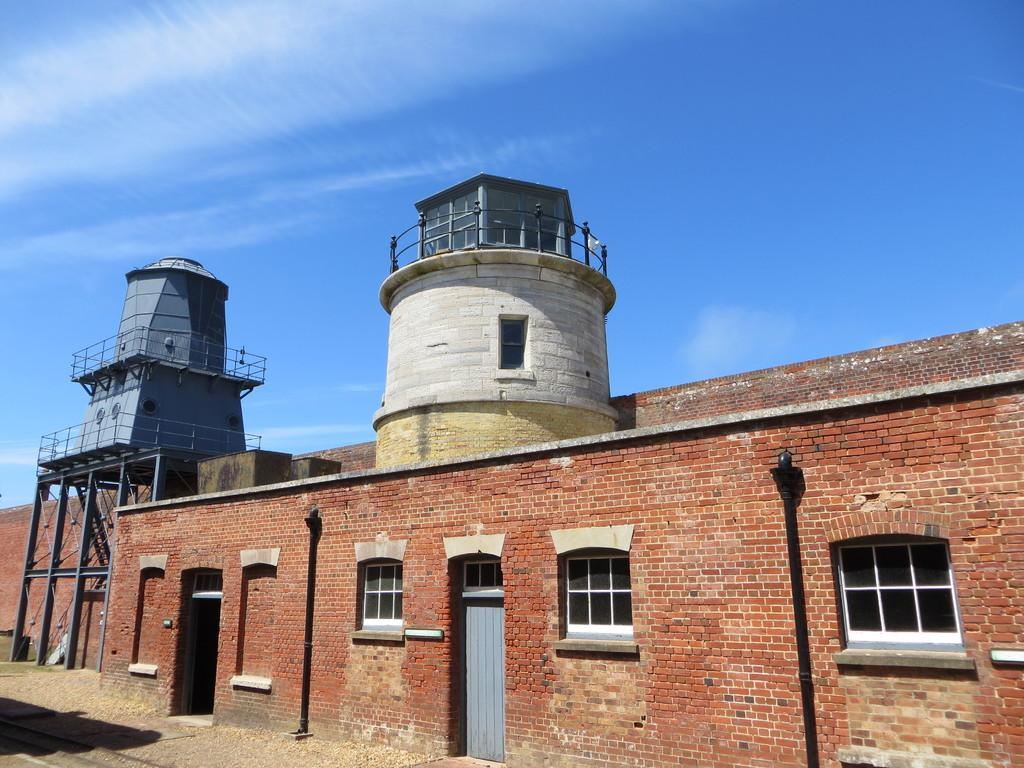What is the main subject of the image? The main subject of the image is the outside view of a building. What part of the natural environment is visible in the image? The sky is visible at the top of the image. What type of mass can be seen in the image? There is no mass present in the image; it features the outside view of a building and the sky. What type of thing is visible in the image? The image features the outside view of a building and the sky, but it does not show any specific "thing." 